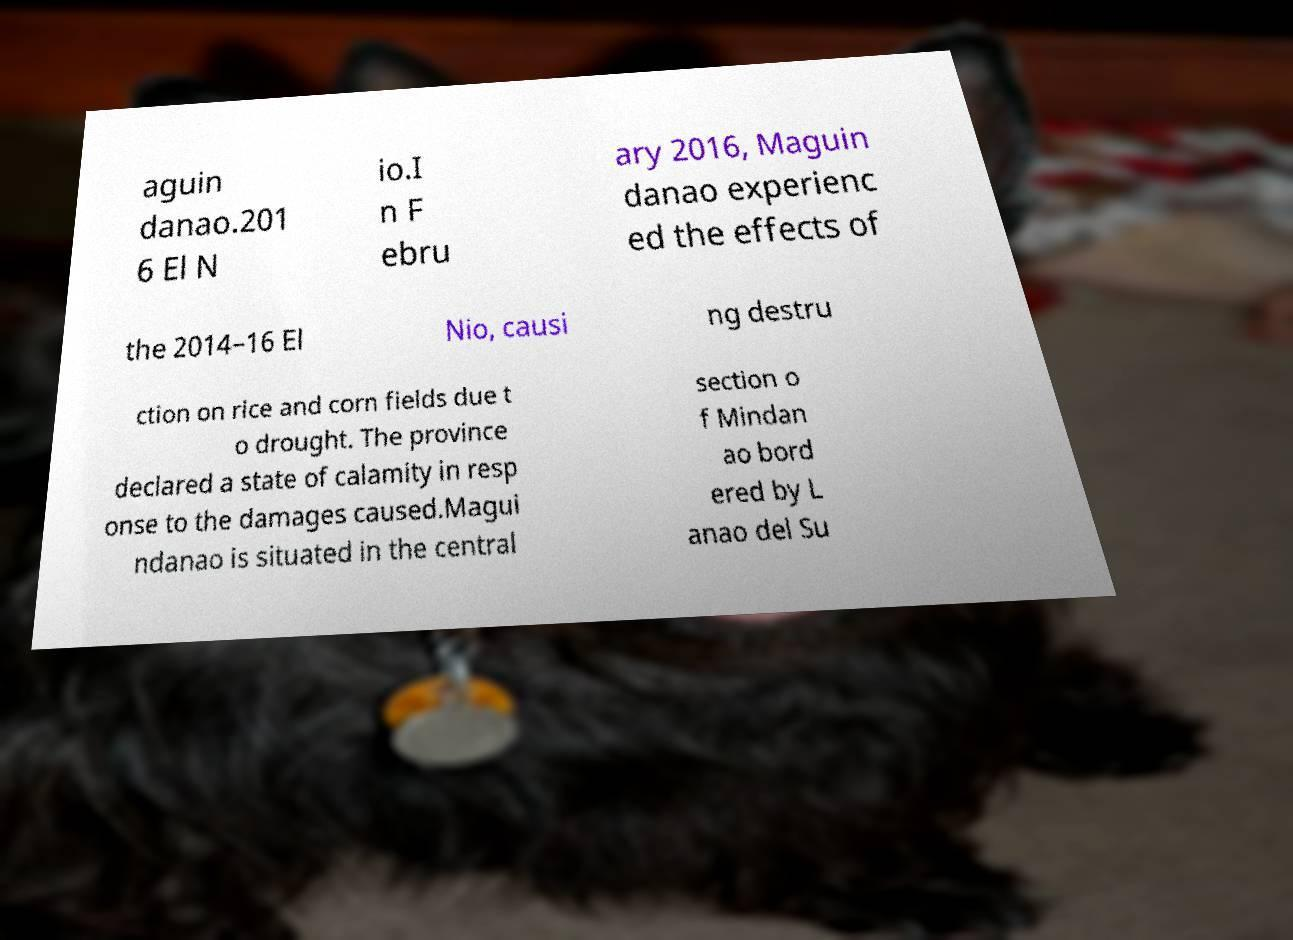I need the written content from this picture converted into text. Can you do that? aguin danao.201 6 El N io.I n F ebru ary 2016, Maguin danao experienc ed the effects of the 2014–16 El Nio, causi ng destru ction on rice and corn fields due t o drought. The province declared a state of calamity in resp onse to the damages caused.Magui ndanao is situated in the central section o f Mindan ao bord ered by L anao del Su 